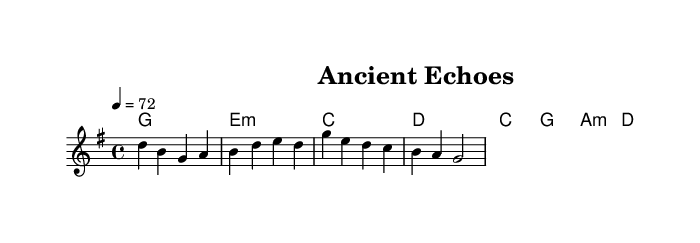what is the key signature of this music? The key signature is G major, which has one sharp (F#).
Answer: G major what is the time signature of this music? The time signature is 4/4, indicating four beats per measure.
Answer: 4/4 what is the tempo marking of this piece? The tempo marking indicates the speed of the piece, set at 72 beats per minute.
Answer: 72 what is the first chord in the verse? The first chord in the verse is G major, as indicated in the harmonies section.
Answer: G how many lines of lyrics are in the chorus? The chorus contains two lines of lyrics, reflecting on ancient themes.
Answer: 2 why is the theme of ancient symbols significant in this music? The theme of ancient symbols adds depth, connecting historical beliefs to modern interpretations. This is emphasized through the lyrics and overall mood of introspection common in country rock.
Answer: Historical connections how does the chord progression support the emotional impact of the lyrics? The chord progression shifts from G to E minor in the verse, creating a reflective and somber tone that complements the introspective nature of the lyrics about ancient symbols and truth. The progression illustrates the contrast between past beliefs and present understanding.
Answer: Reflective tone 